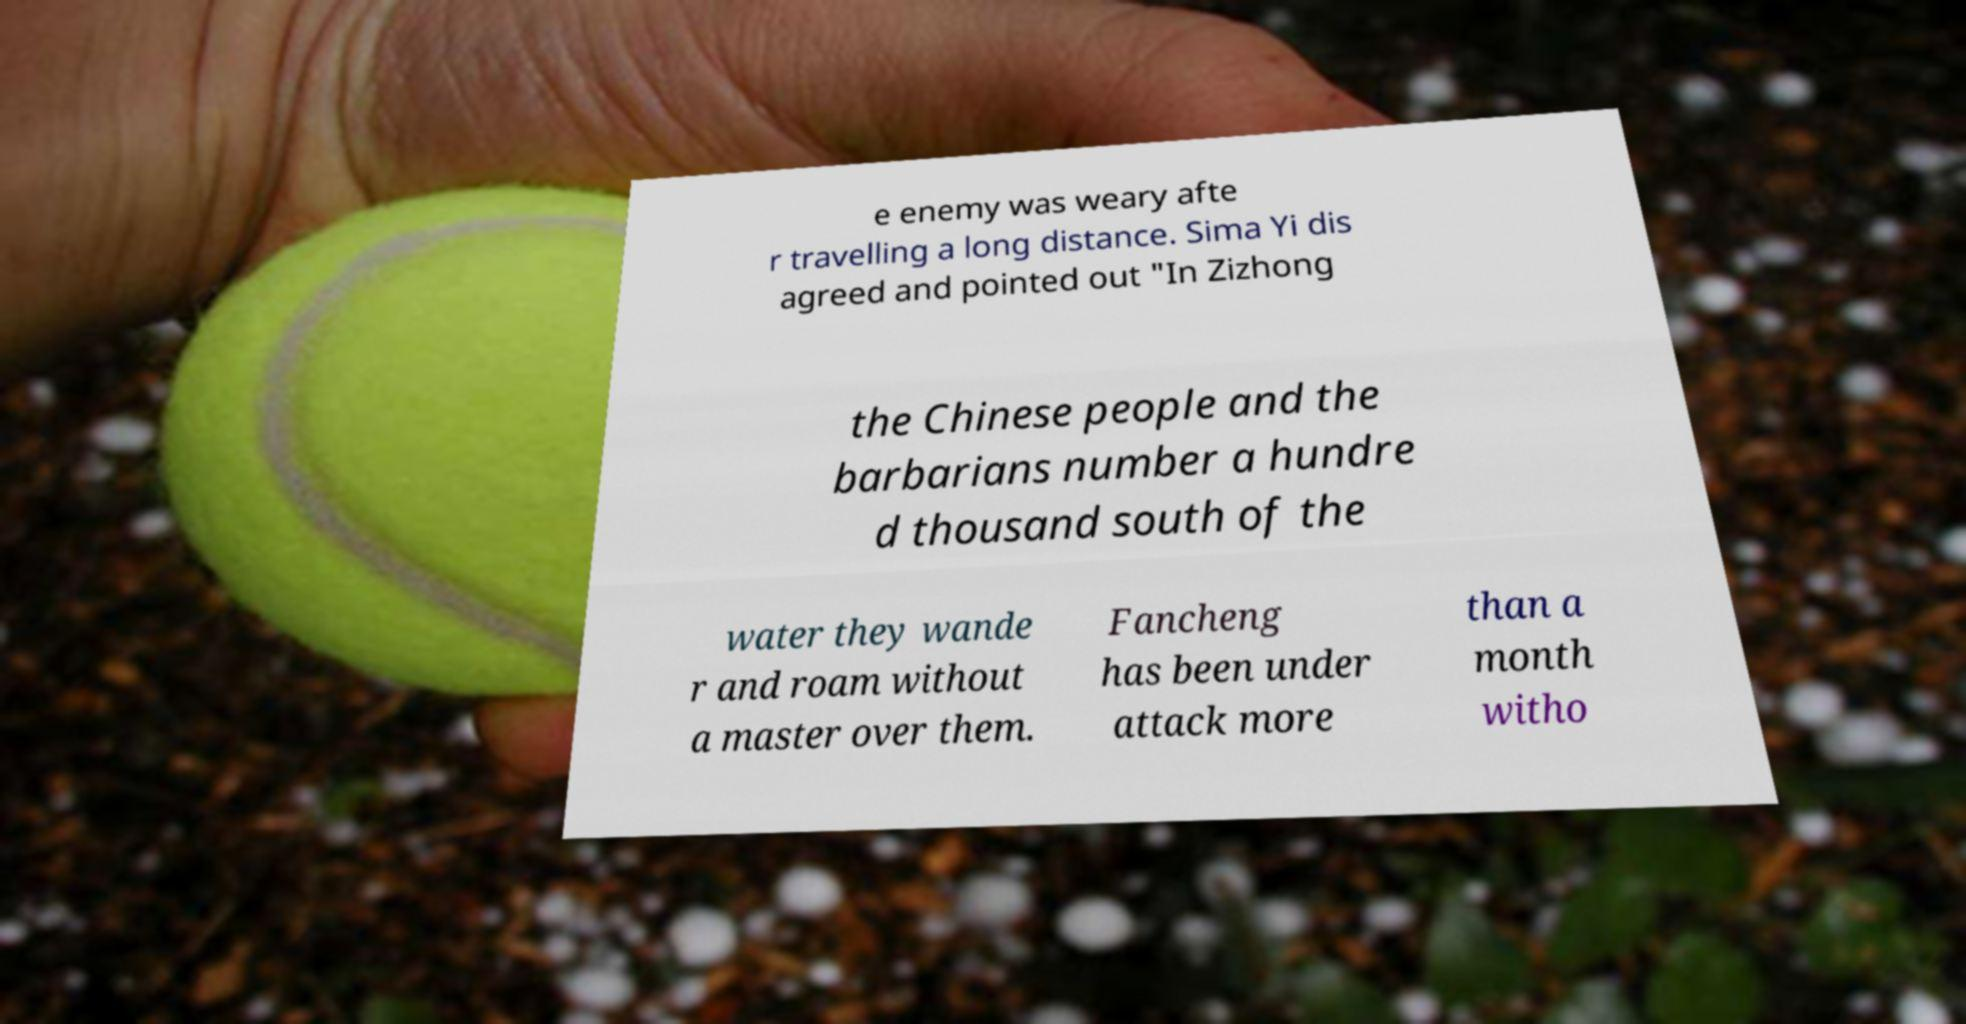Please identify and transcribe the text found in this image. e enemy was weary afte r travelling a long distance. Sima Yi dis agreed and pointed out "In Zizhong the Chinese people and the barbarians number a hundre d thousand south of the water they wande r and roam without a master over them. Fancheng has been under attack more than a month witho 